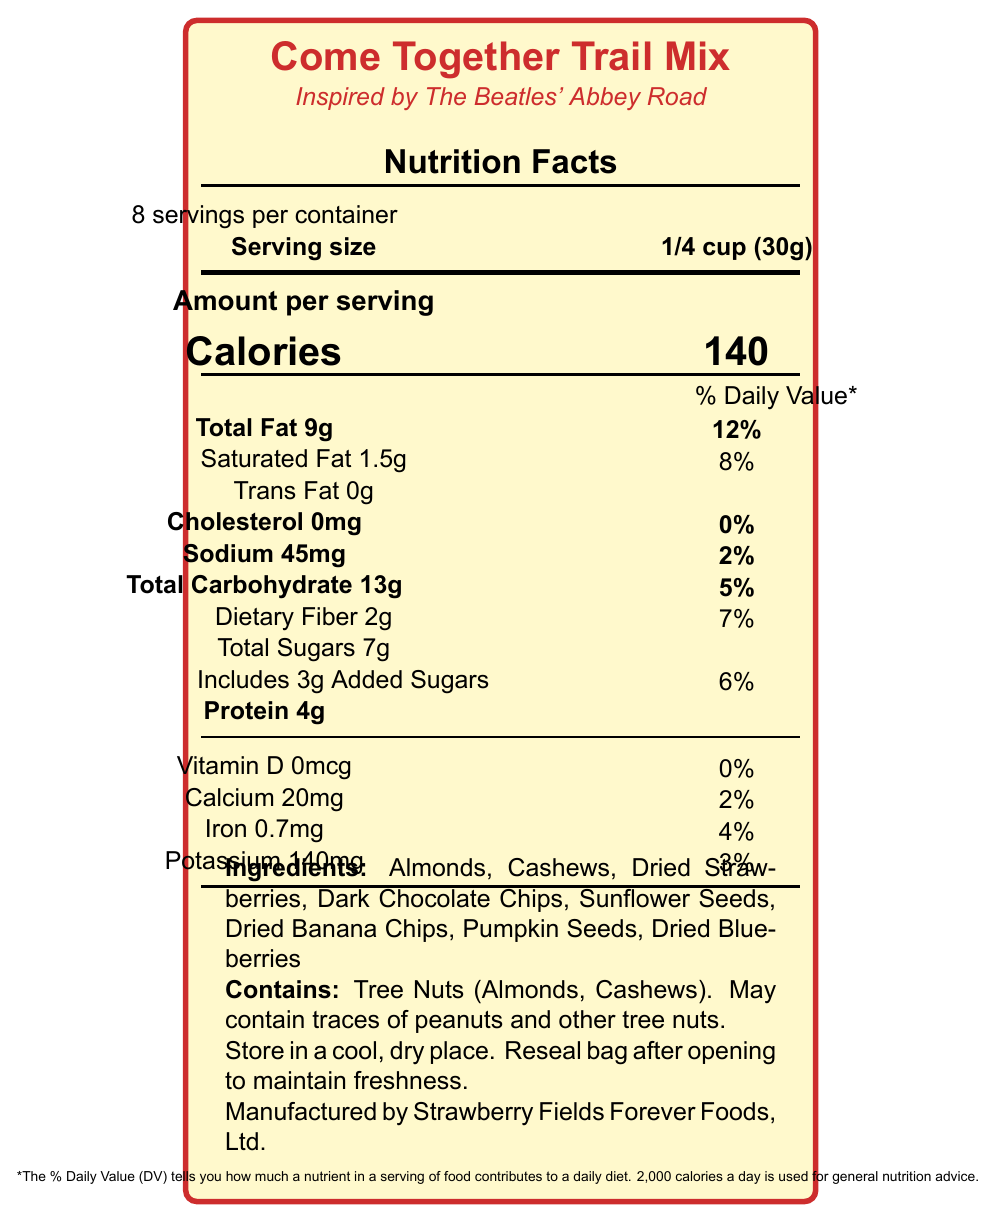What is the serving size? The document specifies that the serving size for the Come Together Trail Mix is 1/4 cup, equivalent to 30 grams.
Answer: 1/4 cup (30g) How many servings are in the container? According to the document, there are 8 servings per container.
Answer: 8 What is the calorie content per serving? The document states that each serving of the Come Together Trail Mix contains 140 calories.
Answer: 140 calories What is the amount of total fat per serving? The total fat per serving is listed as 9 grams on the document.
Answer: 9g What percentage of the daily value does the saturated fat content per serving represent? The document shows that the saturated fat content per serving represents 8% of the daily value.
Answer: 8% Does the product contain any trans fat? The document indicates that the product contains 0 grams of trans fat.
Answer: No What is the amount of protein per serving? The document states that there are 4 grams of protein per serving.
Answer: 4g What is the main idea of this document? The document gives a detailed breakdown of the nutrient content per serving, the list of ingredients, any potential allergens, and storage instructions for the "Come Together Trail Mix."
Answer: The document provides nutritional information for the "Come Together Trail Mix," including macronutrient content, ingredients, allergens, and other relevant product details. How much dietary fiber is present per serving, and what percentage of the daily value does it contribute? The document states that each serving contains 2 grams of dietary fiber, which contributes 7% of the daily value.
Answer: 2g, 7% Multiple-choice: Which of the following ingredients is not listed in the document? 
A. Almonds 
B. Walnuts 
C. Dark Chocolate Chips 
D. Dried Banana Chips The document lists Almonds, Dark Chocolate Chips, and Dried Banana Chips among the ingredients but does not mention Walnuts.
Answer: B Multiple-choice: What is the percentage daily value of sodium in one serving?
1. 0%
2. 2%
3. 4%
4. 6% The document states that the daily value percentage of sodium per serving is 2%.
Answer: 2 Is there any added sugar in the product? The document specifies that the total sugars include 3 grams of added sugars.
Answer: Yes What should you do to maintain the freshness of the trail mix? The document recommends storing the trail mix in a cool, dry place and resealing the bag after opening to maintain freshness.
Answer: Store in a cool, dry place. Reseal bag after opening. What is the daily value percentage for calcium in each serving? According to the document, each serving contains 20mg of calcium, which is 2% of the daily value.
Answer: 2% Unanswerable: What is the price of the Come Together Trail Mix? The document does not provide any information about the price of the product.
Answer: Cannot be determined 